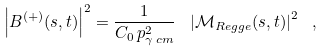Convert formula to latex. <formula><loc_0><loc_0><loc_500><loc_500>\left | B ^ { ( + ) } ( s , t ) \right | ^ { 2 } = \frac { 1 } { C _ { 0 } \, p _ { \gamma \, c m } ^ { 2 } } \ \left | \mathcal { M } _ { R e g g e } ( s , t ) \right | ^ { 2 } \ ,</formula> 